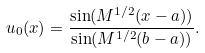Convert formula to latex. <formula><loc_0><loc_0><loc_500><loc_500>u _ { 0 } ( x ) = \frac { \sin ( M ^ { 1 / 2 } ( x - a ) ) } { \sin ( M ^ { 1 / 2 } ( b - a ) ) } .</formula> 